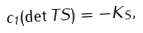<formula> <loc_0><loc_0><loc_500><loc_500>c _ { 1 } ( \det T S ) = - K _ { S } ,</formula> 